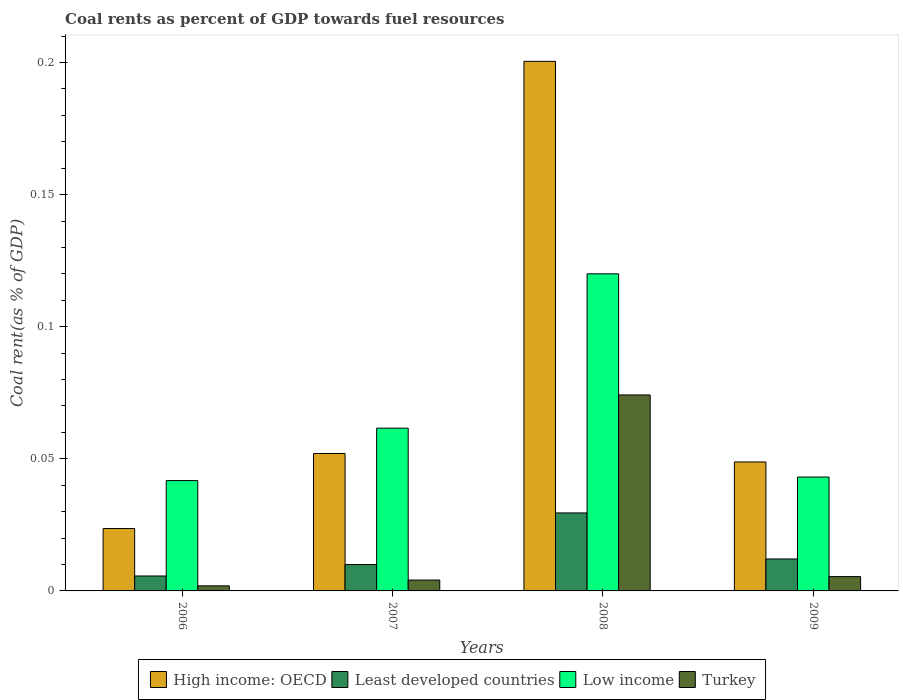How many groups of bars are there?
Your answer should be very brief. 4. Are the number of bars on each tick of the X-axis equal?
Offer a very short reply. Yes. How many bars are there on the 2nd tick from the left?
Offer a terse response. 4. How many bars are there on the 4th tick from the right?
Your answer should be very brief. 4. What is the coal rent in Turkey in 2008?
Your answer should be very brief. 0.07. Across all years, what is the maximum coal rent in Turkey?
Keep it short and to the point. 0.07. Across all years, what is the minimum coal rent in Low income?
Your answer should be compact. 0.04. In which year was the coal rent in Least developed countries maximum?
Provide a short and direct response. 2008. In which year was the coal rent in Turkey minimum?
Offer a terse response. 2006. What is the total coal rent in High income: OECD in the graph?
Provide a succinct answer. 0.32. What is the difference between the coal rent in Least developed countries in 2006 and that in 2007?
Provide a succinct answer. -0. What is the difference between the coal rent in Low income in 2007 and the coal rent in Least developed countries in 2008?
Keep it short and to the point. 0.03. What is the average coal rent in Low income per year?
Your answer should be compact. 0.07. In the year 2008, what is the difference between the coal rent in Low income and coal rent in High income: OECD?
Your answer should be compact. -0.08. What is the ratio of the coal rent in Least developed countries in 2006 to that in 2009?
Make the answer very short. 0.47. Is the coal rent in Turkey in 2006 less than that in 2007?
Provide a succinct answer. Yes. What is the difference between the highest and the second highest coal rent in Turkey?
Ensure brevity in your answer.  0.07. What is the difference between the highest and the lowest coal rent in Turkey?
Ensure brevity in your answer.  0.07. In how many years, is the coal rent in Low income greater than the average coal rent in Low income taken over all years?
Provide a succinct answer. 1. Is it the case that in every year, the sum of the coal rent in Turkey and coal rent in Low income is greater than the sum of coal rent in Least developed countries and coal rent in High income: OECD?
Offer a terse response. No. What does the 1st bar from the left in 2009 represents?
Provide a succinct answer. High income: OECD. What does the 4th bar from the right in 2007 represents?
Offer a terse response. High income: OECD. Is it the case that in every year, the sum of the coal rent in Turkey and coal rent in Low income is greater than the coal rent in Least developed countries?
Provide a succinct answer. Yes. Are all the bars in the graph horizontal?
Provide a short and direct response. No. How many years are there in the graph?
Provide a short and direct response. 4. What is the difference between two consecutive major ticks on the Y-axis?
Offer a terse response. 0.05. Does the graph contain any zero values?
Offer a very short reply. No. Does the graph contain grids?
Ensure brevity in your answer.  No. Where does the legend appear in the graph?
Keep it short and to the point. Bottom center. How many legend labels are there?
Provide a short and direct response. 4. How are the legend labels stacked?
Your response must be concise. Horizontal. What is the title of the graph?
Provide a short and direct response. Coal rents as percent of GDP towards fuel resources. Does "Congo (Republic)" appear as one of the legend labels in the graph?
Make the answer very short. No. What is the label or title of the X-axis?
Ensure brevity in your answer.  Years. What is the label or title of the Y-axis?
Give a very brief answer. Coal rent(as % of GDP). What is the Coal rent(as % of GDP) of High income: OECD in 2006?
Give a very brief answer. 0.02. What is the Coal rent(as % of GDP) of Least developed countries in 2006?
Your answer should be very brief. 0.01. What is the Coal rent(as % of GDP) in Low income in 2006?
Your answer should be very brief. 0.04. What is the Coal rent(as % of GDP) of Turkey in 2006?
Give a very brief answer. 0. What is the Coal rent(as % of GDP) of High income: OECD in 2007?
Your answer should be very brief. 0.05. What is the Coal rent(as % of GDP) of Least developed countries in 2007?
Give a very brief answer. 0.01. What is the Coal rent(as % of GDP) in Low income in 2007?
Provide a short and direct response. 0.06. What is the Coal rent(as % of GDP) of Turkey in 2007?
Provide a short and direct response. 0. What is the Coal rent(as % of GDP) of High income: OECD in 2008?
Your response must be concise. 0.2. What is the Coal rent(as % of GDP) in Least developed countries in 2008?
Provide a succinct answer. 0.03. What is the Coal rent(as % of GDP) in Low income in 2008?
Provide a succinct answer. 0.12. What is the Coal rent(as % of GDP) in Turkey in 2008?
Give a very brief answer. 0.07. What is the Coal rent(as % of GDP) in High income: OECD in 2009?
Provide a succinct answer. 0.05. What is the Coal rent(as % of GDP) of Least developed countries in 2009?
Your answer should be compact. 0.01. What is the Coal rent(as % of GDP) in Low income in 2009?
Your response must be concise. 0.04. What is the Coal rent(as % of GDP) in Turkey in 2009?
Your answer should be very brief. 0.01. Across all years, what is the maximum Coal rent(as % of GDP) of High income: OECD?
Ensure brevity in your answer.  0.2. Across all years, what is the maximum Coal rent(as % of GDP) in Least developed countries?
Offer a very short reply. 0.03. Across all years, what is the maximum Coal rent(as % of GDP) in Low income?
Your answer should be compact. 0.12. Across all years, what is the maximum Coal rent(as % of GDP) of Turkey?
Your answer should be compact. 0.07. Across all years, what is the minimum Coal rent(as % of GDP) of High income: OECD?
Offer a very short reply. 0.02. Across all years, what is the minimum Coal rent(as % of GDP) in Least developed countries?
Provide a succinct answer. 0.01. Across all years, what is the minimum Coal rent(as % of GDP) of Low income?
Ensure brevity in your answer.  0.04. Across all years, what is the minimum Coal rent(as % of GDP) of Turkey?
Your answer should be very brief. 0. What is the total Coal rent(as % of GDP) of High income: OECD in the graph?
Give a very brief answer. 0.32. What is the total Coal rent(as % of GDP) of Least developed countries in the graph?
Your response must be concise. 0.06. What is the total Coal rent(as % of GDP) in Low income in the graph?
Provide a succinct answer. 0.27. What is the total Coal rent(as % of GDP) of Turkey in the graph?
Offer a terse response. 0.09. What is the difference between the Coal rent(as % of GDP) of High income: OECD in 2006 and that in 2007?
Keep it short and to the point. -0.03. What is the difference between the Coal rent(as % of GDP) of Least developed countries in 2006 and that in 2007?
Keep it short and to the point. -0. What is the difference between the Coal rent(as % of GDP) of Low income in 2006 and that in 2007?
Ensure brevity in your answer.  -0.02. What is the difference between the Coal rent(as % of GDP) of Turkey in 2006 and that in 2007?
Make the answer very short. -0. What is the difference between the Coal rent(as % of GDP) of High income: OECD in 2006 and that in 2008?
Offer a very short reply. -0.18. What is the difference between the Coal rent(as % of GDP) of Least developed countries in 2006 and that in 2008?
Keep it short and to the point. -0.02. What is the difference between the Coal rent(as % of GDP) of Low income in 2006 and that in 2008?
Give a very brief answer. -0.08. What is the difference between the Coal rent(as % of GDP) in Turkey in 2006 and that in 2008?
Offer a very short reply. -0.07. What is the difference between the Coal rent(as % of GDP) of High income: OECD in 2006 and that in 2009?
Provide a succinct answer. -0.03. What is the difference between the Coal rent(as % of GDP) in Least developed countries in 2006 and that in 2009?
Provide a short and direct response. -0.01. What is the difference between the Coal rent(as % of GDP) in Low income in 2006 and that in 2009?
Offer a very short reply. -0. What is the difference between the Coal rent(as % of GDP) in Turkey in 2006 and that in 2009?
Your answer should be compact. -0. What is the difference between the Coal rent(as % of GDP) of High income: OECD in 2007 and that in 2008?
Provide a succinct answer. -0.15. What is the difference between the Coal rent(as % of GDP) in Least developed countries in 2007 and that in 2008?
Ensure brevity in your answer.  -0.02. What is the difference between the Coal rent(as % of GDP) of Low income in 2007 and that in 2008?
Give a very brief answer. -0.06. What is the difference between the Coal rent(as % of GDP) of Turkey in 2007 and that in 2008?
Make the answer very short. -0.07. What is the difference between the Coal rent(as % of GDP) in High income: OECD in 2007 and that in 2009?
Provide a succinct answer. 0. What is the difference between the Coal rent(as % of GDP) of Least developed countries in 2007 and that in 2009?
Offer a very short reply. -0. What is the difference between the Coal rent(as % of GDP) of Low income in 2007 and that in 2009?
Your answer should be very brief. 0.02. What is the difference between the Coal rent(as % of GDP) in Turkey in 2007 and that in 2009?
Keep it short and to the point. -0. What is the difference between the Coal rent(as % of GDP) in High income: OECD in 2008 and that in 2009?
Your answer should be very brief. 0.15. What is the difference between the Coal rent(as % of GDP) in Least developed countries in 2008 and that in 2009?
Provide a short and direct response. 0.02. What is the difference between the Coal rent(as % of GDP) of Low income in 2008 and that in 2009?
Make the answer very short. 0.08. What is the difference between the Coal rent(as % of GDP) in Turkey in 2008 and that in 2009?
Your response must be concise. 0.07. What is the difference between the Coal rent(as % of GDP) of High income: OECD in 2006 and the Coal rent(as % of GDP) of Least developed countries in 2007?
Give a very brief answer. 0.01. What is the difference between the Coal rent(as % of GDP) in High income: OECD in 2006 and the Coal rent(as % of GDP) in Low income in 2007?
Offer a very short reply. -0.04. What is the difference between the Coal rent(as % of GDP) in High income: OECD in 2006 and the Coal rent(as % of GDP) in Turkey in 2007?
Provide a short and direct response. 0.02. What is the difference between the Coal rent(as % of GDP) of Least developed countries in 2006 and the Coal rent(as % of GDP) of Low income in 2007?
Keep it short and to the point. -0.06. What is the difference between the Coal rent(as % of GDP) of Least developed countries in 2006 and the Coal rent(as % of GDP) of Turkey in 2007?
Ensure brevity in your answer.  0. What is the difference between the Coal rent(as % of GDP) of Low income in 2006 and the Coal rent(as % of GDP) of Turkey in 2007?
Provide a succinct answer. 0.04. What is the difference between the Coal rent(as % of GDP) in High income: OECD in 2006 and the Coal rent(as % of GDP) in Least developed countries in 2008?
Ensure brevity in your answer.  -0.01. What is the difference between the Coal rent(as % of GDP) in High income: OECD in 2006 and the Coal rent(as % of GDP) in Low income in 2008?
Ensure brevity in your answer.  -0.1. What is the difference between the Coal rent(as % of GDP) of High income: OECD in 2006 and the Coal rent(as % of GDP) of Turkey in 2008?
Make the answer very short. -0.05. What is the difference between the Coal rent(as % of GDP) in Least developed countries in 2006 and the Coal rent(as % of GDP) in Low income in 2008?
Your response must be concise. -0.11. What is the difference between the Coal rent(as % of GDP) of Least developed countries in 2006 and the Coal rent(as % of GDP) of Turkey in 2008?
Keep it short and to the point. -0.07. What is the difference between the Coal rent(as % of GDP) in Low income in 2006 and the Coal rent(as % of GDP) in Turkey in 2008?
Ensure brevity in your answer.  -0.03. What is the difference between the Coal rent(as % of GDP) of High income: OECD in 2006 and the Coal rent(as % of GDP) of Least developed countries in 2009?
Your answer should be very brief. 0.01. What is the difference between the Coal rent(as % of GDP) of High income: OECD in 2006 and the Coal rent(as % of GDP) of Low income in 2009?
Offer a terse response. -0.02. What is the difference between the Coal rent(as % of GDP) of High income: OECD in 2006 and the Coal rent(as % of GDP) of Turkey in 2009?
Your answer should be compact. 0.02. What is the difference between the Coal rent(as % of GDP) in Least developed countries in 2006 and the Coal rent(as % of GDP) in Low income in 2009?
Make the answer very short. -0.04. What is the difference between the Coal rent(as % of GDP) of Low income in 2006 and the Coal rent(as % of GDP) of Turkey in 2009?
Your response must be concise. 0.04. What is the difference between the Coal rent(as % of GDP) in High income: OECD in 2007 and the Coal rent(as % of GDP) in Least developed countries in 2008?
Keep it short and to the point. 0.02. What is the difference between the Coal rent(as % of GDP) in High income: OECD in 2007 and the Coal rent(as % of GDP) in Low income in 2008?
Your response must be concise. -0.07. What is the difference between the Coal rent(as % of GDP) of High income: OECD in 2007 and the Coal rent(as % of GDP) of Turkey in 2008?
Offer a terse response. -0.02. What is the difference between the Coal rent(as % of GDP) in Least developed countries in 2007 and the Coal rent(as % of GDP) in Low income in 2008?
Your answer should be compact. -0.11. What is the difference between the Coal rent(as % of GDP) in Least developed countries in 2007 and the Coal rent(as % of GDP) in Turkey in 2008?
Your answer should be compact. -0.06. What is the difference between the Coal rent(as % of GDP) of Low income in 2007 and the Coal rent(as % of GDP) of Turkey in 2008?
Give a very brief answer. -0.01. What is the difference between the Coal rent(as % of GDP) of High income: OECD in 2007 and the Coal rent(as % of GDP) of Least developed countries in 2009?
Your answer should be very brief. 0.04. What is the difference between the Coal rent(as % of GDP) in High income: OECD in 2007 and the Coal rent(as % of GDP) in Low income in 2009?
Offer a terse response. 0.01. What is the difference between the Coal rent(as % of GDP) of High income: OECD in 2007 and the Coal rent(as % of GDP) of Turkey in 2009?
Ensure brevity in your answer.  0.05. What is the difference between the Coal rent(as % of GDP) in Least developed countries in 2007 and the Coal rent(as % of GDP) in Low income in 2009?
Provide a short and direct response. -0.03. What is the difference between the Coal rent(as % of GDP) in Least developed countries in 2007 and the Coal rent(as % of GDP) in Turkey in 2009?
Make the answer very short. 0. What is the difference between the Coal rent(as % of GDP) of Low income in 2007 and the Coal rent(as % of GDP) of Turkey in 2009?
Offer a very short reply. 0.06. What is the difference between the Coal rent(as % of GDP) in High income: OECD in 2008 and the Coal rent(as % of GDP) in Least developed countries in 2009?
Your response must be concise. 0.19. What is the difference between the Coal rent(as % of GDP) of High income: OECD in 2008 and the Coal rent(as % of GDP) of Low income in 2009?
Keep it short and to the point. 0.16. What is the difference between the Coal rent(as % of GDP) of High income: OECD in 2008 and the Coal rent(as % of GDP) of Turkey in 2009?
Make the answer very short. 0.2. What is the difference between the Coal rent(as % of GDP) of Least developed countries in 2008 and the Coal rent(as % of GDP) of Low income in 2009?
Offer a very short reply. -0.01. What is the difference between the Coal rent(as % of GDP) of Least developed countries in 2008 and the Coal rent(as % of GDP) of Turkey in 2009?
Keep it short and to the point. 0.02. What is the difference between the Coal rent(as % of GDP) in Low income in 2008 and the Coal rent(as % of GDP) in Turkey in 2009?
Make the answer very short. 0.11. What is the average Coal rent(as % of GDP) of High income: OECD per year?
Your answer should be compact. 0.08. What is the average Coal rent(as % of GDP) of Least developed countries per year?
Your answer should be compact. 0.01. What is the average Coal rent(as % of GDP) in Low income per year?
Your answer should be very brief. 0.07. What is the average Coal rent(as % of GDP) in Turkey per year?
Provide a short and direct response. 0.02. In the year 2006, what is the difference between the Coal rent(as % of GDP) in High income: OECD and Coal rent(as % of GDP) in Least developed countries?
Offer a terse response. 0.02. In the year 2006, what is the difference between the Coal rent(as % of GDP) in High income: OECD and Coal rent(as % of GDP) in Low income?
Offer a very short reply. -0.02. In the year 2006, what is the difference between the Coal rent(as % of GDP) in High income: OECD and Coal rent(as % of GDP) in Turkey?
Offer a terse response. 0.02. In the year 2006, what is the difference between the Coal rent(as % of GDP) of Least developed countries and Coal rent(as % of GDP) of Low income?
Provide a short and direct response. -0.04. In the year 2006, what is the difference between the Coal rent(as % of GDP) of Least developed countries and Coal rent(as % of GDP) of Turkey?
Make the answer very short. 0. In the year 2006, what is the difference between the Coal rent(as % of GDP) of Low income and Coal rent(as % of GDP) of Turkey?
Your response must be concise. 0.04. In the year 2007, what is the difference between the Coal rent(as % of GDP) of High income: OECD and Coal rent(as % of GDP) of Least developed countries?
Offer a very short reply. 0.04. In the year 2007, what is the difference between the Coal rent(as % of GDP) of High income: OECD and Coal rent(as % of GDP) of Low income?
Your response must be concise. -0.01. In the year 2007, what is the difference between the Coal rent(as % of GDP) in High income: OECD and Coal rent(as % of GDP) in Turkey?
Your response must be concise. 0.05. In the year 2007, what is the difference between the Coal rent(as % of GDP) of Least developed countries and Coal rent(as % of GDP) of Low income?
Ensure brevity in your answer.  -0.05. In the year 2007, what is the difference between the Coal rent(as % of GDP) of Least developed countries and Coal rent(as % of GDP) of Turkey?
Offer a very short reply. 0.01. In the year 2007, what is the difference between the Coal rent(as % of GDP) in Low income and Coal rent(as % of GDP) in Turkey?
Offer a terse response. 0.06. In the year 2008, what is the difference between the Coal rent(as % of GDP) in High income: OECD and Coal rent(as % of GDP) in Least developed countries?
Keep it short and to the point. 0.17. In the year 2008, what is the difference between the Coal rent(as % of GDP) of High income: OECD and Coal rent(as % of GDP) of Low income?
Provide a succinct answer. 0.08. In the year 2008, what is the difference between the Coal rent(as % of GDP) in High income: OECD and Coal rent(as % of GDP) in Turkey?
Provide a succinct answer. 0.13. In the year 2008, what is the difference between the Coal rent(as % of GDP) of Least developed countries and Coal rent(as % of GDP) of Low income?
Provide a succinct answer. -0.09. In the year 2008, what is the difference between the Coal rent(as % of GDP) of Least developed countries and Coal rent(as % of GDP) of Turkey?
Keep it short and to the point. -0.04. In the year 2008, what is the difference between the Coal rent(as % of GDP) of Low income and Coal rent(as % of GDP) of Turkey?
Offer a terse response. 0.05. In the year 2009, what is the difference between the Coal rent(as % of GDP) in High income: OECD and Coal rent(as % of GDP) in Least developed countries?
Keep it short and to the point. 0.04. In the year 2009, what is the difference between the Coal rent(as % of GDP) in High income: OECD and Coal rent(as % of GDP) in Low income?
Your response must be concise. 0.01. In the year 2009, what is the difference between the Coal rent(as % of GDP) in High income: OECD and Coal rent(as % of GDP) in Turkey?
Offer a terse response. 0.04. In the year 2009, what is the difference between the Coal rent(as % of GDP) in Least developed countries and Coal rent(as % of GDP) in Low income?
Your response must be concise. -0.03. In the year 2009, what is the difference between the Coal rent(as % of GDP) of Least developed countries and Coal rent(as % of GDP) of Turkey?
Provide a short and direct response. 0.01. In the year 2009, what is the difference between the Coal rent(as % of GDP) in Low income and Coal rent(as % of GDP) in Turkey?
Ensure brevity in your answer.  0.04. What is the ratio of the Coal rent(as % of GDP) of High income: OECD in 2006 to that in 2007?
Your answer should be very brief. 0.45. What is the ratio of the Coal rent(as % of GDP) in Least developed countries in 2006 to that in 2007?
Give a very brief answer. 0.57. What is the ratio of the Coal rent(as % of GDP) of Low income in 2006 to that in 2007?
Give a very brief answer. 0.68. What is the ratio of the Coal rent(as % of GDP) of Turkey in 2006 to that in 2007?
Provide a short and direct response. 0.46. What is the ratio of the Coal rent(as % of GDP) of High income: OECD in 2006 to that in 2008?
Your answer should be very brief. 0.12. What is the ratio of the Coal rent(as % of GDP) in Least developed countries in 2006 to that in 2008?
Your response must be concise. 0.19. What is the ratio of the Coal rent(as % of GDP) of Low income in 2006 to that in 2008?
Provide a short and direct response. 0.35. What is the ratio of the Coal rent(as % of GDP) in Turkey in 2006 to that in 2008?
Your response must be concise. 0.03. What is the ratio of the Coal rent(as % of GDP) of High income: OECD in 2006 to that in 2009?
Keep it short and to the point. 0.48. What is the ratio of the Coal rent(as % of GDP) in Least developed countries in 2006 to that in 2009?
Provide a succinct answer. 0.47. What is the ratio of the Coal rent(as % of GDP) of Low income in 2006 to that in 2009?
Offer a terse response. 0.97. What is the ratio of the Coal rent(as % of GDP) in Turkey in 2006 to that in 2009?
Give a very brief answer. 0.35. What is the ratio of the Coal rent(as % of GDP) of High income: OECD in 2007 to that in 2008?
Offer a terse response. 0.26. What is the ratio of the Coal rent(as % of GDP) of Least developed countries in 2007 to that in 2008?
Your response must be concise. 0.34. What is the ratio of the Coal rent(as % of GDP) of Low income in 2007 to that in 2008?
Provide a succinct answer. 0.51. What is the ratio of the Coal rent(as % of GDP) of Turkey in 2007 to that in 2008?
Make the answer very short. 0.06. What is the ratio of the Coal rent(as % of GDP) of High income: OECD in 2007 to that in 2009?
Give a very brief answer. 1.07. What is the ratio of the Coal rent(as % of GDP) of Least developed countries in 2007 to that in 2009?
Provide a short and direct response. 0.83. What is the ratio of the Coal rent(as % of GDP) of Low income in 2007 to that in 2009?
Your answer should be very brief. 1.43. What is the ratio of the Coal rent(as % of GDP) in Turkey in 2007 to that in 2009?
Offer a terse response. 0.76. What is the ratio of the Coal rent(as % of GDP) of High income: OECD in 2008 to that in 2009?
Your answer should be very brief. 4.11. What is the ratio of the Coal rent(as % of GDP) in Least developed countries in 2008 to that in 2009?
Offer a terse response. 2.44. What is the ratio of the Coal rent(as % of GDP) of Low income in 2008 to that in 2009?
Your answer should be compact. 2.78. What is the ratio of the Coal rent(as % of GDP) of Turkey in 2008 to that in 2009?
Your answer should be compact. 13.69. What is the difference between the highest and the second highest Coal rent(as % of GDP) in High income: OECD?
Your answer should be compact. 0.15. What is the difference between the highest and the second highest Coal rent(as % of GDP) of Least developed countries?
Keep it short and to the point. 0.02. What is the difference between the highest and the second highest Coal rent(as % of GDP) in Low income?
Your response must be concise. 0.06. What is the difference between the highest and the second highest Coal rent(as % of GDP) of Turkey?
Provide a succinct answer. 0.07. What is the difference between the highest and the lowest Coal rent(as % of GDP) of High income: OECD?
Provide a succinct answer. 0.18. What is the difference between the highest and the lowest Coal rent(as % of GDP) in Least developed countries?
Offer a terse response. 0.02. What is the difference between the highest and the lowest Coal rent(as % of GDP) of Low income?
Make the answer very short. 0.08. What is the difference between the highest and the lowest Coal rent(as % of GDP) in Turkey?
Make the answer very short. 0.07. 